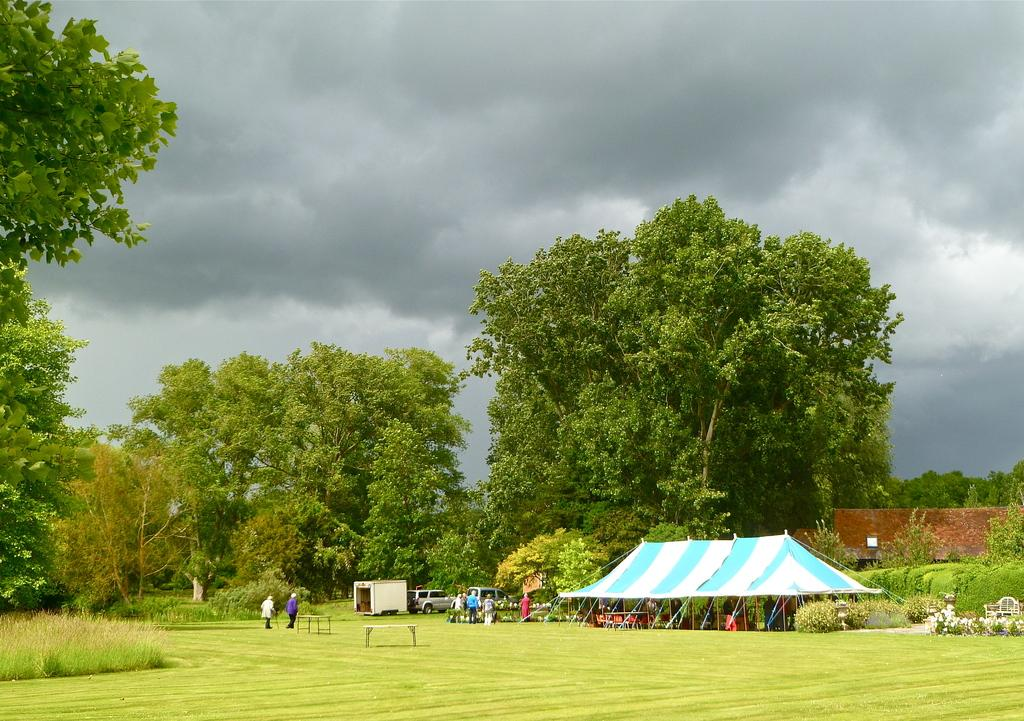What type of vegetation is present in the foreground of the image? There is grass, plants, and trees in the foreground of the image. What type of structure can be seen in the foreground of the image? There is a tent in the foreground of the image. What type of transportation is visible in the foreground of the image? There are vehicles in the foreground of the image. What activity are the persons in the foreground of the image engaged in? There are persons walking in the foreground of the image. What type of structure can be seen in the background of the image? There is a building in the background of the image. What can be seen in the sky in the background of the image? There are clouds and the sky is visible in the background of the image. How many quarters are being used to hold up the chin of the person in the image? There are no quarters or chin-related actions depicted in the image. What day of the week is it in the image? The day of the week is not mentioned or depicted in the image. 